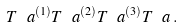<formula> <loc_0><loc_0><loc_500><loc_500>T ^ { \ } a ^ { ( 1 ) } T ^ { \ } a ^ { ( 2 ) } T ^ { \ } a ^ { ( 3 ) } T ^ { \ } a \, .</formula> 